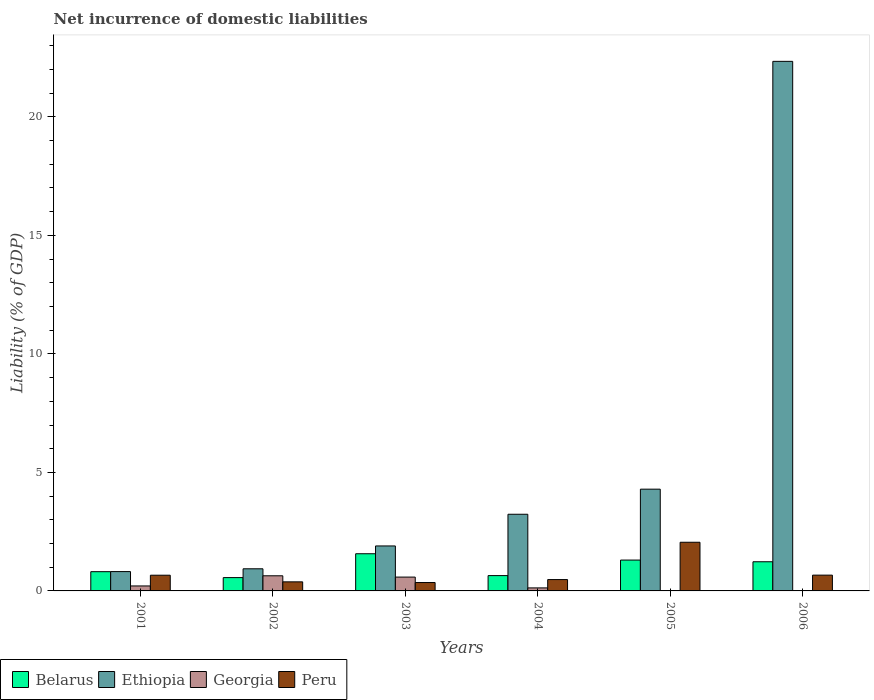How many groups of bars are there?
Provide a short and direct response. 6. Are the number of bars per tick equal to the number of legend labels?
Keep it short and to the point. No. Are the number of bars on each tick of the X-axis equal?
Provide a short and direct response. No. How many bars are there on the 6th tick from the left?
Offer a very short reply. 3. What is the net incurrence of domestic liabilities in Ethiopia in 2006?
Your answer should be compact. 22.34. Across all years, what is the maximum net incurrence of domestic liabilities in Georgia?
Your answer should be very brief. 0.64. Across all years, what is the minimum net incurrence of domestic liabilities in Peru?
Keep it short and to the point. 0.35. What is the total net incurrence of domestic liabilities in Georgia in the graph?
Keep it short and to the point. 1.56. What is the difference between the net incurrence of domestic liabilities in Peru in 2002 and that in 2003?
Keep it short and to the point. 0.03. What is the difference between the net incurrence of domestic liabilities in Peru in 2003 and the net incurrence of domestic liabilities in Georgia in 2005?
Provide a short and direct response. 0.35. What is the average net incurrence of domestic liabilities in Georgia per year?
Your answer should be very brief. 0.26. In the year 2003, what is the difference between the net incurrence of domestic liabilities in Peru and net incurrence of domestic liabilities in Georgia?
Provide a succinct answer. -0.23. In how many years, is the net incurrence of domestic liabilities in Ethiopia greater than 11 %?
Your answer should be compact. 1. What is the ratio of the net incurrence of domestic liabilities in Peru in 2003 to that in 2005?
Offer a terse response. 0.17. Is the net incurrence of domestic liabilities in Ethiopia in 2003 less than that in 2006?
Give a very brief answer. Yes. Is the difference between the net incurrence of domestic liabilities in Peru in 2001 and 2004 greater than the difference between the net incurrence of domestic liabilities in Georgia in 2001 and 2004?
Keep it short and to the point. Yes. What is the difference between the highest and the second highest net incurrence of domestic liabilities in Peru?
Your answer should be very brief. 1.39. What is the difference between the highest and the lowest net incurrence of domestic liabilities in Georgia?
Your response must be concise. 0.64. How many bars are there?
Provide a short and direct response. 22. Are all the bars in the graph horizontal?
Ensure brevity in your answer.  No. How many years are there in the graph?
Give a very brief answer. 6. Are the values on the major ticks of Y-axis written in scientific E-notation?
Provide a short and direct response. No. Does the graph contain any zero values?
Your answer should be very brief. Yes. Where does the legend appear in the graph?
Give a very brief answer. Bottom left. How many legend labels are there?
Offer a terse response. 4. How are the legend labels stacked?
Keep it short and to the point. Horizontal. What is the title of the graph?
Keep it short and to the point. Net incurrence of domestic liabilities. Does "Thailand" appear as one of the legend labels in the graph?
Ensure brevity in your answer.  No. What is the label or title of the X-axis?
Offer a terse response. Years. What is the label or title of the Y-axis?
Keep it short and to the point. Liability (% of GDP). What is the Liability (% of GDP) of Belarus in 2001?
Give a very brief answer. 0.81. What is the Liability (% of GDP) in Ethiopia in 2001?
Ensure brevity in your answer.  0.82. What is the Liability (% of GDP) of Georgia in 2001?
Offer a very short reply. 0.21. What is the Liability (% of GDP) of Peru in 2001?
Your answer should be compact. 0.66. What is the Liability (% of GDP) in Belarus in 2002?
Offer a very short reply. 0.56. What is the Liability (% of GDP) in Ethiopia in 2002?
Offer a terse response. 0.93. What is the Liability (% of GDP) in Georgia in 2002?
Give a very brief answer. 0.64. What is the Liability (% of GDP) in Peru in 2002?
Provide a short and direct response. 0.38. What is the Liability (% of GDP) in Belarus in 2003?
Provide a succinct answer. 1.57. What is the Liability (% of GDP) in Ethiopia in 2003?
Make the answer very short. 1.9. What is the Liability (% of GDP) of Georgia in 2003?
Your response must be concise. 0.58. What is the Liability (% of GDP) in Peru in 2003?
Your answer should be very brief. 0.35. What is the Liability (% of GDP) of Belarus in 2004?
Your answer should be compact. 0.65. What is the Liability (% of GDP) of Ethiopia in 2004?
Ensure brevity in your answer.  3.23. What is the Liability (% of GDP) of Georgia in 2004?
Ensure brevity in your answer.  0.13. What is the Liability (% of GDP) of Peru in 2004?
Provide a succinct answer. 0.48. What is the Liability (% of GDP) in Belarus in 2005?
Ensure brevity in your answer.  1.3. What is the Liability (% of GDP) in Ethiopia in 2005?
Your answer should be very brief. 4.29. What is the Liability (% of GDP) in Georgia in 2005?
Provide a succinct answer. 0. What is the Liability (% of GDP) of Peru in 2005?
Keep it short and to the point. 2.05. What is the Liability (% of GDP) of Belarus in 2006?
Provide a short and direct response. 1.23. What is the Liability (% of GDP) of Ethiopia in 2006?
Provide a short and direct response. 22.34. What is the Liability (% of GDP) in Peru in 2006?
Make the answer very short. 0.67. Across all years, what is the maximum Liability (% of GDP) of Belarus?
Give a very brief answer. 1.57. Across all years, what is the maximum Liability (% of GDP) in Ethiopia?
Provide a succinct answer. 22.34. Across all years, what is the maximum Liability (% of GDP) of Georgia?
Provide a short and direct response. 0.64. Across all years, what is the maximum Liability (% of GDP) of Peru?
Offer a terse response. 2.05. Across all years, what is the minimum Liability (% of GDP) in Belarus?
Give a very brief answer. 0.56. Across all years, what is the minimum Liability (% of GDP) in Ethiopia?
Your answer should be compact. 0.82. Across all years, what is the minimum Liability (% of GDP) in Georgia?
Give a very brief answer. 0. Across all years, what is the minimum Liability (% of GDP) of Peru?
Your answer should be very brief. 0.35. What is the total Liability (% of GDP) of Belarus in the graph?
Ensure brevity in your answer.  6.12. What is the total Liability (% of GDP) in Ethiopia in the graph?
Provide a short and direct response. 33.52. What is the total Liability (% of GDP) of Georgia in the graph?
Keep it short and to the point. 1.56. What is the total Liability (% of GDP) in Peru in the graph?
Make the answer very short. 4.6. What is the difference between the Liability (% of GDP) in Belarus in 2001 and that in 2002?
Make the answer very short. 0.25. What is the difference between the Liability (% of GDP) of Ethiopia in 2001 and that in 2002?
Keep it short and to the point. -0.12. What is the difference between the Liability (% of GDP) of Georgia in 2001 and that in 2002?
Ensure brevity in your answer.  -0.43. What is the difference between the Liability (% of GDP) of Peru in 2001 and that in 2002?
Keep it short and to the point. 0.28. What is the difference between the Liability (% of GDP) of Belarus in 2001 and that in 2003?
Provide a short and direct response. -0.76. What is the difference between the Liability (% of GDP) in Ethiopia in 2001 and that in 2003?
Your answer should be very brief. -1.08. What is the difference between the Liability (% of GDP) of Georgia in 2001 and that in 2003?
Provide a succinct answer. -0.37. What is the difference between the Liability (% of GDP) in Peru in 2001 and that in 2003?
Keep it short and to the point. 0.31. What is the difference between the Liability (% of GDP) in Belarus in 2001 and that in 2004?
Your response must be concise. 0.17. What is the difference between the Liability (% of GDP) of Ethiopia in 2001 and that in 2004?
Ensure brevity in your answer.  -2.42. What is the difference between the Liability (% of GDP) in Georgia in 2001 and that in 2004?
Offer a terse response. 0.08. What is the difference between the Liability (% of GDP) in Peru in 2001 and that in 2004?
Your response must be concise. 0.18. What is the difference between the Liability (% of GDP) in Belarus in 2001 and that in 2005?
Your answer should be compact. -0.49. What is the difference between the Liability (% of GDP) of Ethiopia in 2001 and that in 2005?
Ensure brevity in your answer.  -3.48. What is the difference between the Liability (% of GDP) in Peru in 2001 and that in 2005?
Offer a terse response. -1.39. What is the difference between the Liability (% of GDP) in Belarus in 2001 and that in 2006?
Ensure brevity in your answer.  -0.42. What is the difference between the Liability (% of GDP) in Ethiopia in 2001 and that in 2006?
Keep it short and to the point. -21.53. What is the difference between the Liability (% of GDP) of Peru in 2001 and that in 2006?
Your answer should be compact. -0. What is the difference between the Liability (% of GDP) in Belarus in 2002 and that in 2003?
Offer a very short reply. -1.01. What is the difference between the Liability (% of GDP) of Ethiopia in 2002 and that in 2003?
Your answer should be compact. -0.96. What is the difference between the Liability (% of GDP) of Georgia in 2002 and that in 2003?
Keep it short and to the point. 0.05. What is the difference between the Liability (% of GDP) in Peru in 2002 and that in 2003?
Your answer should be compact. 0.03. What is the difference between the Liability (% of GDP) of Belarus in 2002 and that in 2004?
Provide a short and direct response. -0.08. What is the difference between the Liability (% of GDP) in Ethiopia in 2002 and that in 2004?
Make the answer very short. -2.3. What is the difference between the Liability (% of GDP) of Georgia in 2002 and that in 2004?
Your answer should be compact. 0.51. What is the difference between the Liability (% of GDP) of Peru in 2002 and that in 2004?
Make the answer very short. -0.1. What is the difference between the Liability (% of GDP) of Belarus in 2002 and that in 2005?
Offer a very short reply. -0.74. What is the difference between the Liability (% of GDP) of Ethiopia in 2002 and that in 2005?
Offer a very short reply. -3.36. What is the difference between the Liability (% of GDP) of Peru in 2002 and that in 2005?
Your answer should be compact. -1.67. What is the difference between the Liability (% of GDP) of Belarus in 2002 and that in 2006?
Your answer should be very brief. -0.67. What is the difference between the Liability (% of GDP) in Ethiopia in 2002 and that in 2006?
Your answer should be compact. -21.41. What is the difference between the Liability (% of GDP) of Peru in 2002 and that in 2006?
Provide a succinct answer. -0.28. What is the difference between the Liability (% of GDP) in Belarus in 2003 and that in 2004?
Your answer should be compact. 0.92. What is the difference between the Liability (% of GDP) in Ethiopia in 2003 and that in 2004?
Your answer should be compact. -1.34. What is the difference between the Liability (% of GDP) in Georgia in 2003 and that in 2004?
Give a very brief answer. 0.46. What is the difference between the Liability (% of GDP) of Peru in 2003 and that in 2004?
Provide a succinct answer. -0.13. What is the difference between the Liability (% of GDP) in Belarus in 2003 and that in 2005?
Keep it short and to the point. 0.27. What is the difference between the Liability (% of GDP) in Ethiopia in 2003 and that in 2005?
Keep it short and to the point. -2.4. What is the difference between the Liability (% of GDP) in Peru in 2003 and that in 2005?
Ensure brevity in your answer.  -1.7. What is the difference between the Liability (% of GDP) of Belarus in 2003 and that in 2006?
Keep it short and to the point. 0.34. What is the difference between the Liability (% of GDP) in Ethiopia in 2003 and that in 2006?
Ensure brevity in your answer.  -20.45. What is the difference between the Liability (% of GDP) in Peru in 2003 and that in 2006?
Provide a succinct answer. -0.31. What is the difference between the Liability (% of GDP) in Belarus in 2004 and that in 2005?
Your answer should be very brief. -0.66. What is the difference between the Liability (% of GDP) of Ethiopia in 2004 and that in 2005?
Offer a very short reply. -1.06. What is the difference between the Liability (% of GDP) of Peru in 2004 and that in 2005?
Offer a very short reply. -1.57. What is the difference between the Liability (% of GDP) in Belarus in 2004 and that in 2006?
Provide a short and direct response. -0.58. What is the difference between the Liability (% of GDP) of Ethiopia in 2004 and that in 2006?
Offer a very short reply. -19.11. What is the difference between the Liability (% of GDP) in Peru in 2004 and that in 2006?
Your answer should be very brief. -0.19. What is the difference between the Liability (% of GDP) in Belarus in 2005 and that in 2006?
Provide a succinct answer. 0.07. What is the difference between the Liability (% of GDP) in Ethiopia in 2005 and that in 2006?
Your answer should be very brief. -18.05. What is the difference between the Liability (% of GDP) in Peru in 2005 and that in 2006?
Keep it short and to the point. 1.39. What is the difference between the Liability (% of GDP) in Belarus in 2001 and the Liability (% of GDP) in Ethiopia in 2002?
Your answer should be compact. -0.12. What is the difference between the Liability (% of GDP) of Belarus in 2001 and the Liability (% of GDP) of Georgia in 2002?
Your answer should be very brief. 0.17. What is the difference between the Liability (% of GDP) in Belarus in 2001 and the Liability (% of GDP) in Peru in 2002?
Provide a short and direct response. 0.43. What is the difference between the Liability (% of GDP) in Ethiopia in 2001 and the Liability (% of GDP) in Georgia in 2002?
Offer a very short reply. 0.18. What is the difference between the Liability (% of GDP) of Ethiopia in 2001 and the Liability (% of GDP) of Peru in 2002?
Provide a succinct answer. 0.43. What is the difference between the Liability (% of GDP) in Georgia in 2001 and the Liability (% of GDP) in Peru in 2002?
Provide a succinct answer. -0.17. What is the difference between the Liability (% of GDP) of Belarus in 2001 and the Liability (% of GDP) of Ethiopia in 2003?
Your answer should be very brief. -1.09. What is the difference between the Liability (% of GDP) in Belarus in 2001 and the Liability (% of GDP) in Georgia in 2003?
Keep it short and to the point. 0.23. What is the difference between the Liability (% of GDP) in Belarus in 2001 and the Liability (% of GDP) in Peru in 2003?
Ensure brevity in your answer.  0.46. What is the difference between the Liability (% of GDP) of Ethiopia in 2001 and the Liability (% of GDP) of Georgia in 2003?
Ensure brevity in your answer.  0.23. What is the difference between the Liability (% of GDP) of Ethiopia in 2001 and the Liability (% of GDP) of Peru in 2003?
Your answer should be very brief. 0.46. What is the difference between the Liability (% of GDP) in Georgia in 2001 and the Liability (% of GDP) in Peru in 2003?
Make the answer very short. -0.14. What is the difference between the Liability (% of GDP) in Belarus in 2001 and the Liability (% of GDP) in Ethiopia in 2004?
Ensure brevity in your answer.  -2.42. What is the difference between the Liability (% of GDP) of Belarus in 2001 and the Liability (% of GDP) of Georgia in 2004?
Offer a terse response. 0.68. What is the difference between the Liability (% of GDP) in Belarus in 2001 and the Liability (% of GDP) in Peru in 2004?
Your answer should be very brief. 0.33. What is the difference between the Liability (% of GDP) in Ethiopia in 2001 and the Liability (% of GDP) in Georgia in 2004?
Provide a short and direct response. 0.69. What is the difference between the Liability (% of GDP) of Ethiopia in 2001 and the Liability (% of GDP) of Peru in 2004?
Your answer should be very brief. 0.34. What is the difference between the Liability (% of GDP) in Georgia in 2001 and the Liability (% of GDP) in Peru in 2004?
Keep it short and to the point. -0.27. What is the difference between the Liability (% of GDP) of Belarus in 2001 and the Liability (% of GDP) of Ethiopia in 2005?
Make the answer very short. -3.48. What is the difference between the Liability (% of GDP) of Belarus in 2001 and the Liability (% of GDP) of Peru in 2005?
Give a very brief answer. -1.24. What is the difference between the Liability (% of GDP) in Ethiopia in 2001 and the Liability (% of GDP) in Peru in 2005?
Provide a short and direct response. -1.24. What is the difference between the Liability (% of GDP) in Georgia in 2001 and the Liability (% of GDP) in Peru in 2005?
Ensure brevity in your answer.  -1.84. What is the difference between the Liability (% of GDP) of Belarus in 2001 and the Liability (% of GDP) of Ethiopia in 2006?
Your answer should be very brief. -21.53. What is the difference between the Liability (% of GDP) in Belarus in 2001 and the Liability (% of GDP) in Peru in 2006?
Offer a very short reply. 0.15. What is the difference between the Liability (% of GDP) in Ethiopia in 2001 and the Liability (% of GDP) in Peru in 2006?
Ensure brevity in your answer.  0.15. What is the difference between the Liability (% of GDP) of Georgia in 2001 and the Liability (% of GDP) of Peru in 2006?
Provide a succinct answer. -0.46. What is the difference between the Liability (% of GDP) of Belarus in 2002 and the Liability (% of GDP) of Ethiopia in 2003?
Your answer should be very brief. -1.34. What is the difference between the Liability (% of GDP) of Belarus in 2002 and the Liability (% of GDP) of Georgia in 2003?
Your answer should be very brief. -0.02. What is the difference between the Liability (% of GDP) in Belarus in 2002 and the Liability (% of GDP) in Peru in 2003?
Give a very brief answer. 0.21. What is the difference between the Liability (% of GDP) in Ethiopia in 2002 and the Liability (% of GDP) in Georgia in 2003?
Your answer should be very brief. 0.35. What is the difference between the Liability (% of GDP) in Ethiopia in 2002 and the Liability (% of GDP) in Peru in 2003?
Your answer should be very brief. 0.58. What is the difference between the Liability (% of GDP) in Georgia in 2002 and the Liability (% of GDP) in Peru in 2003?
Offer a terse response. 0.28. What is the difference between the Liability (% of GDP) in Belarus in 2002 and the Liability (% of GDP) in Ethiopia in 2004?
Your answer should be compact. -2.67. What is the difference between the Liability (% of GDP) of Belarus in 2002 and the Liability (% of GDP) of Georgia in 2004?
Your answer should be compact. 0.43. What is the difference between the Liability (% of GDP) in Belarus in 2002 and the Liability (% of GDP) in Peru in 2004?
Give a very brief answer. 0.08. What is the difference between the Liability (% of GDP) of Ethiopia in 2002 and the Liability (% of GDP) of Georgia in 2004?
Ensure brevity in your answer.  0.81. What is the difference between the Liability (% of GDP) in Ethiopia in 2002 and the Liability (% of GDP) in Peru in 2004?
Provide a short and direct response. 0.45. What is the difference between the Liability (% of GDP) of Georgia in 2002 and the Liability (% of GDP) of Peru in 2004?
Offer a very short reply. 0.16. What is the difference between the Liability (% of GDP) in Belarus in 2002 and the Liability (% of GDP) in Ethiopia in 2005?
Provide a succinct answer. -3.73. What is the difference between the Liability (% of GDP) in Belarus in 2002 and the Liability (% of GDP) in Peru in 2005?
Offer a terse response. -1.49. What is the difference between the Liability (% of GDP) of Ethiopia in 2002 and the Liability (% of GDP) of Peru in 2005?
Your answer should be very brief. -1.12. What is the difference between the Liability (% of GDP) of Georgia in 2002 and the Liability (% of GDP) of Peru in 2005?
Provide a succinct answer. -1.41. What is the difference between the Liability (% of GDP) in Belarus in 2002 and the Liability (% of GDP) in Ethiopia in 2006?
Keep it short and to the point. -21.78. What is the difference between the Liability (% of GDP) in Belarus in 2002 and the Liability (% of GDP) in Peru in 2006?
Your answer should be compact. -0.1. What is the difference between the Liability (% of GDP) of Ethiopia in 2002 and the Liability (% of GDP) of Peru in 2006?
Offer a very short reply. 0.27. What is the difference between the Liability (% of GDP) in Georgia in 2002 and the Liability (% of GDP) in Peru in 2006?
Give a very brief answer. -0.03. What is the difference between the Liability (% of GDP) in Belarus in 2003 and the Liability (% of GDP) in Ethiopia in 2004?
Your answer should be compact. -1.67. What is the difference between the Liability (% of GDP) in Belarus in 2003 and the Liability (% of GDP) in Georgia in 2004?
Make the answer very short. 1.44. What is the difference between the Liability (% of GDP) in Belarus in 2003 and the Liability (% of GDP) in Peru in 2004?
Give a very brief answer. 1.09. What is the difference between the Liability (% of GDP) of Ethiopia in 2003 and the Liability (% of GDP) of Georgia in 2004?
Provide a short and direct response. 1.77. What is the difference between the Liability (% of GDP) in Ethiopia in 2003 and the Liability (% of GDP) in Peru in 2004?
Make the answer very short. 1.42. What is the difference between the Liability (% of GDP) in Georgia in 2003 and the Liability (% of GDP) in Peru in 2004?
Provide a succinct answer. 0.1. What is the difference between the Liability (% of GDP) of Belarus in 2003 and the Liability (% of GDP) of Ethiopia in 2005?
Provide a short and direct response. -2.72. What is the difference between the Liability (% of GDP) of Belarus in 2003 and the Liability (% of GDP) of Peru in 2005?
Keep it short and to the point. -0.48. What is the difference between the Liability (% of GDP) in Ethiopia in 2003 and the Liability (% of GDP) in Peru in 2005?
Your answer should be compact. -0.16. What is the difference between the Liability (% of GDP) of Georgia in 2003 and the Liability (% of GDP) of Peru in 2005?
Make the answer very short. -1.47. What is the difference between the Liability (% of GDP) in Belarus in 2003 and the Liability (% of GDP) in Ethiopia in 2006?
Give a very brief answer. -20.77. What is the difference between the Liability (% of GDP) in Belarus in 2003 and the Liability (% of GDP) in Peru in 2006?
Offer a terse response. 0.9. What is the difference between the Liability (% of GDP) of Ethiopia in 2003 and the Liability (% of GDP) of Peru in 2006?
Ensure brevity in your answer.  1.23. What is the difference between the Liability (% of GDP) in Georgia in 2003 and the Liability (% of GDP) in Peru in 2006?
Ensure brevity in your answer.  -0.08. What is the difference between the Liability (% of GDP) of Belarus in 2004 and the Liability (% of GDP) of Ethiopia in 2005?
Ensure brevity in your answer.  -3.65. What is the difference between the Liability (% of GDP) in Belarus in 2004 and the Liability (% of GDP) in Peru in 2005?
Your answer should be very brief. -1.41. What is the difference between the Liability (% of GDP) in Ethiopia in 2004 and the Liability (% of GDP) in Peru in 2005?
Keep it short and to the point. 1.18. What is the difference between the Liability (% of GDP) of Georgia in 2004 and the Liability (% of GDP) of Peru in 2005?
Make the answer very short. -1.93. What is the difference between the Liability (% of GDP) of Belarus in 2004 and the Liability (% of GDP) of Ethiopia in 2006?
Your answer should be very brief. -21.7. What is the difference between the Liability (% of GDP) of Belarus in 2004 and the Liability (% of GDP) of Peru in 2006?
Give a very brief answer. -0.02. What is the difference between the Liability (% of GDP) in Ethiopia in 2004 and the Liability (% of GDP) in Peru in 2006?
Your response must be concise. 2.57. What is the difference between the Liability (% of GDP) of Georgia in 2004 and the Liability (% of GDP) of Peru in 2006?
Give a very brief answer. -0.54. What is the difference between the Liability (% of GDP) in Belarus in 2005 and the Liability (% of GDP) in Ethiopia in 2006?
Your answer should be very brief. -21.04. What is the difference between the Liability (% of GDP) of Belarus in 2005 and the Liability (% of GDP) of Peru in 2006?
Provide a succinct answer. 0.64. What is the difference between the Liability (% of GDP) of Ethiopia in 2005 and the Liability (% of GDP) of Peru in 2006?
Ensure brevity in your answer.  3.63. What is the average Liability (% of GDP) of Ethiopia per year?
Provide a short and direct response. 5.59. What is the average Liability (% of GDP) of Georgia per year?
Make the answer very short. 0.26. What is the average Liability (% of GDP) of Peru per year?
Keep it short and to the point. 0.77. In the year 2001, what is the difference between the Liability (% of GDP) of Belarus and Liability (% of GDP) of Ethiopia?
Keep it short and to the point. -0. In the year 2001, what is the difference between the Liability (% of GDP) of Belarus and Liability (% of GDP) of Georgia?
Ensure brevity in your answer.  0.6. In the year 2001, what is the difference between the Liability (% of GDP) of Belarus and Liability (% of GDP) of Peru?
Offer a terse response. 0.15. In the year 2001, what is the difference between the Liability (% of GDP) in Ethiopia and Liability (% of GDP) in Georgia?
Provide a succinct answer. 0.61. In the year 2001, what is the difference between the Liability (% of GDP) in Ethiopia and Liability (% of GDP) in Peru?
Give a very brief answer. 0.15. In the year 2001, what is the difference between the Liability (% of GDP) of Georgia and Liability (% of GDP) of Peru?
Provide a succinct answer. -0.45. In the year 2002, what is the difference between the Liability (% of GDP) in Belarus and Liability (% of GDP) in Ethiopia?
Offer a very short reply. -0.37. In the year 2002, what is the difference between the Liability (% of GDP) in Belarus and Liability (% of GDP) in Georgia?
Provide a short and direct response. -0.08. In the year 2002, what is the difference between the Liability (% of GDP) of Belarus and Liability (% of GDP) of Peru?
Give a very brief answer. 0.18. In the year 2002, what is the difference between the Liability (% of GDP) in Ethiopia and Liability (% of GDP) in Georgia?
Provide a succinct answer. 0.3. In the year 2002, what is the difference between the Liability (% of GDP) in Ethiopia and Liability (% of GDP) in Peru?
Your answer should be very brief. 0.55. In the year 2002, what is the difference between the Liability (% of GDP) in Georgia and Liability (% of GDP) in Peru?
Offer a terse response. 0.26. In the year 2003, what is the difference between the Liability (% of GDP) in Belarus and Liability (% of GDP) in Ethiopia?
Ensure brevity in your answer.  -0.33. In the year 2003, what is the difference between the Liability (% of GDP) of Belarus and Liability (% of GDP) of Georgia?
Keep it short and to the point. 0.98. In the year 2003, what is the difference between the Liability (% of GDP) of Belarus and Liability (% of GDP) of Peru?
Provide a short and direct response. 1.21. In the year 2003, what is the difference between the Liability (% of GDP) of Ethiopia and Liability (% of GDP) of Georgia?
Your response must be concise. 1.31. In the year 2003, what is the difference between the Liability (% of GDP) in Ethiopia and Liability (% of GDP) in Peru?
Keep it short and to the point. 1.54. In the year 2003, what is the difference between the Liability (% of GDP) in Georgia and Liability (% of GDP) in Peru?
Give a very brief answer. 0.23. In the year 2004, what is the difference between the Liability (% of GDP) in Belarus and Liability (% of GDP) in Ethiopia?
Ensure brevity in your answer.  -2.59. In the year 2004, what is the difference between the Liability (% of GDP) of Belarus and Liability (% of GDP) of Georgia?
Offer a terse response. 0.52. In the year 2004, what is the difference between the Liability (% of GDP) of Belarus and Liability (% of GDP) of Peru?
Ensure brevity in your answer.  0.17. In the year 2004, what is the difference between the Liability (% of GDP) in Ethiopia and Liability (% of GDP) in Georgia?
Offer a terse response. 3.11. In the year 2004, what is the difference between the Liability (% of GDP) of Ethiopia and Liability (% of GDP) of Peru?
Your response must be concise. 2.76. In the year 2004, what is the difference between the Liability (% of GDP) in Georgia and Liability (% of GDP) in Peru?
Make the answer very short. -0.35. In the year 2005, what is the difference between the Liability (% of GDP) in Belarus and Liability (% of GDP) in Ethiopia?
Offer a very short reply. -2.99. In the year 2005, what is the difference between the Liability (% of GDP) of Belarus and Liability (% of GDP) of Peru?
Your answer should be very brief. -0.75. In the year 2005, what is the difference between the Liability (% of GDP) in Ethiopia and Liability (% of GDP) in Peru?
Your answer should be very brief. 2.24. In the year 2006, what is the difference between the Liability (% of GDP) in Belarus and Liability (% of GDP) in Ethiopia?
Offer a very short reply. -21.11. In the year 2006, what is the difference between the Liability (% of GDP) in Belarus and Liability (% of GDP) in Peru?
Offer a terse response. 0.56. In the year 2006, what is the difference between the Liability (% of GDP) of Ethiopia and Liability (% of GDP) of Peru?
Your response must be concise. 21.68. What is the ratio of the Liability (% of GDP) in Belarus in 2001 to that in 2002?
Your response must be concise. 1.44. What is the ratio of the Liability (% of GDP) in Ethiopia in 2001 to that in 2002?
Give a very brief answer. 0.87. What is the ratio of the Liability (% of GDP) of Georgia in 2001 to that in 2002?
Keep it short and to the point. 0.33. What is the ratio of the Liability (% of GDP) in Peru in 2001 to that in 2002?
Provide a succinct answer. 1.73. What is the ratio of the Liability (% of GDP) of Belarus in 2001 to that in 2003?
Offer a terse response. 0.52. What is the ratio of the Liability (% of GDP) in Ethiopia in 2001 to that in 2003?
Offer a very short reply. 0.43. What is the ratio of the Liability (% of GDP) of Georgia in 2001 to that in 2003?
Your answer should be compact. 0.36. What is the ratio of the Liability (% of GDP) of Peru in 2001 to that in 2003?
Your answer should be compact. 1.87. What is the ratio of the Liability (% of GDP) in Belarus in 2001 to that in 2004?
Give a very brief answer. 1.26. What is the ratio of the Liability (% of GDP) in Ethiopia in 2001 to that in 2004?
Offer a terse response. 0.25. What is the ratio of the Liability (% of GDP) of Georgia in 2001 to that in 2004?
Offer a terse response. 1.65. What is the ratio of the Liability (% of GDP) in Peru in 2001 to that in 2004?
Make the answer very short. 1.38. What is the ratio of the Liability (% of GDP) of Belarus in 2001 to that in 2005?
Give a very brief answer. 0.62. What is the ratio of the Liability (% of GDP) in Ethiopia in 2001 to that in 2005?
Provide a succinct answer. 0.19. What is the ratio of the Liability (% of GDP) of Peru in 2001 to that in 2005?
Offer a terse response. 0.32. What is the ratio of the Liability (% of GDP) of Belarus in 2001 to that in 2006?
Offer a terse response. 0.66. What is the ratio of the Liability (% of GDP) in Ethiopia in 2001 to that in 2006?
Your answer should be compact. 0.04. What is the ratio of the Liability (% of GDP) in Belarus in 2002 to that in 2003?
Provide a short and direct response. 0.36. What is the ratio of the Liability (% of GDP) of Ethiopia in 2002 to that in 2003?
Your answer should be very brief. 0.49. What is the ratio of the Liability (% of GDP) of Georgia in 2002 to that in 2003?
Keep it short and to the point. 1.09. What is the ratio of the Liability (% of GDP) in Peru in 2002 to that in 2003?
Make the answer very short. 1.08. What is the ratio of the Liability (% of GDP) of Belarus in 2002 to that in 2004?
Make the answer very short. 0.87. What is the ratio of the Liability (% of GDP) in Ethiopia in 2002 to that in 2004?
Keep it short and to the point. 0.29. What is the ratio of the Liability (% of GDP) in Georgia in 2002 to that in 2004?
Ensure brevity in your answer.  5.02. What is the ratio of the Liability (% of GDP) in Peru in 2002 to that in 2004?
Ensure brevity in your answer.  0.8. What is the ratio of the Liability (% of GDP) of Belarus in 2002 to that in 2005?
Keep it short and to the point. 0.43. What is the ratio of the Liability (% of GDP) of Ethiopia in 2002 to that in 2005?
Provide a short and direct response. 0.22. What is the ratio of the Liability (% of GDP) in Peru in 2002 to that in 2005?
Your response must be concise. 0.19. What is the ratio of the Liability (% of GDP) in Belarus in 2002 to that in 2006?
Your answer should be compact. 0.46. What is the ratio of the Liability (% of GDP) in Ethiopia in 2002 to that in 2006?
Your answer should be very brief. 0.04. What is the ratio of the Liability (% of GDP) of Peru in 2002 to that in 2006?
Give a very brief answer. 0.57. What is the ratio of the Liability (% of GDP) in Belarus in 2003 to that in 2004?
Provide a short and direct response. 2.43. What is the ratio of the Liability (% of GDP) of Ethiopia in 2003 to that in 2004?
Offer a very short reply. 0.59. What is the ratio of the Liability (% of GDP) of Georgia in 2003 to that in 2004?
Offer a terse response. 4.59. What is the ratio of the Liability (% of GDP) of Peru in 2003 to that in 2004?
Provide a succinct answer. 0.74. What is the ratio of the Liability (% of GDP) of Belarus in 2003 to that in 2005?
Provide a short and direct response. 1.21. What is the ratio of the Liability (% of GDP) in Ethiopia in 2003 to that in 2005?
Provide a short and direct response. 0.44. What is the ratio of the Liability (% of GDP) of Peru in 2003 to that in 2005?
Keep it short and to the point. 0.17. What is the ratio of the Liability (% of GDP) of Belarus in 2003 to that in 2006?
Your answer should be very brief. 1.27. What is the ratio of the Liability (% of GDP) in Ethiopia in 2003 to that in 2006?
Provide a succinct answer. 0.08. What is the ratio of the Liability (% of GDP) of Peru in 2003 to that in 2006?
Give a very brief answer. 0.53. What is the ratio of the Liability (% of GDP) in Belarus in 2004 to that in 2005?
Provide a succinct answer. 0.5. What is the ratio of the Liability (% of GDP) in Ethiopia in 2004 to that in 2005?
Provide a short and direct response. 0.75. What is the ratio of the Liability (% of GDP) of Peru in 2004 to that in 2005?
Provide a short and direct response. 0.23. What is the ratio of the Liability (% of GDP) in Belarus in 2004 to that in 2006?
Provide a succinct answer. 0.53. What is the ratio of the Liability (% of GDP) of Ethiopia in 2004 to that in 2006?
Keep it short and to the point. 0.14. What is the ratio of the Liability (% of GDP) of Peru in 2004 to that in 2006?
Offer a very short reply. 0.72. What is the ratio of the Liability (% of GDP) in Belarus in 2005 to that in 2006?
Your answer should be very brief. 1.06. What is the ratio of the Liability (% of GDP) in Ethiopia in 2005 to that in 2006?
Provide a succinct answer. 0.19. What is the ratio of the Liability (% of GDP) in Peru in 2005 to that in 2006?
Offer a very short reply. 3.08. What is the difference between the highest and the second highest Liability (% of GDP) in Belarus?
Ensure brevity in your answer.  0.27. What is the difference between the highest and the second highest Liability (% of GDP) in Ethiopia?
Your answer should be compact. 18.05. What is the difference between the highest and the second highest Liability (% of GDP) of Georgia?
Your answer should be very brief. 0.05. What is the difference between the highest and the second highest Liability (% of GDP) of Peru?
Offer a very short reply. 1.39. What is the difference between the highest and the lowest Liability (% of GDP) of Belarus?
Offer a very short reply. 1.01. What is the difference between the highest and the lowest Liability (% of GDP) of Ethiopia?
Provide a succinct answer. 21.53. What is the difference between the highest and the lowest Liability (% of GDP) of Georgia?
Offer a terse response. 0.64. What is the difference between the highest and the lowest Liability (% of GDP) of Peru?
Provide a succinct answer. 1.7. 